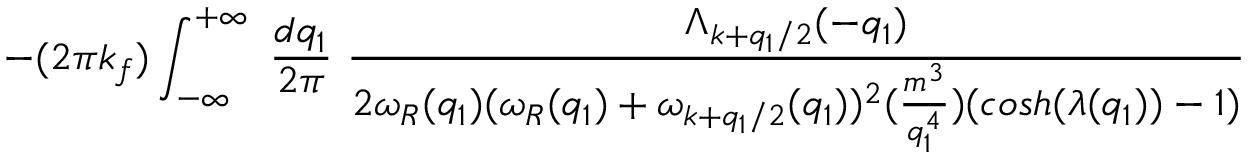<formula> <loc_0><loc_0><loc_500><loc_500>- ( 2 \pi k _ { f } ) \int _ { - \infty } ^ { + \infty } \frac { d q _ { 1 } } { 2 \pi } \frac { \Lambda _ { k + q _ { 1 } / 2 } ( - q _ { 1 } ) } { 2 \omega _ { R } ( q _ { 1 } ) ( \omega _ { R } ( q _ { 1 } ) + \omega _ { k + q _ { 1 } / 2 } ( q _ { 1 } ) ) ^ { 2 } ( \frac { m ^ { 3 } } { q _ { 1 } ^ { 4 } } ) ( \cosh ( \lambda ( q _ { 1 } ) ) - 1 ) }</formula> 